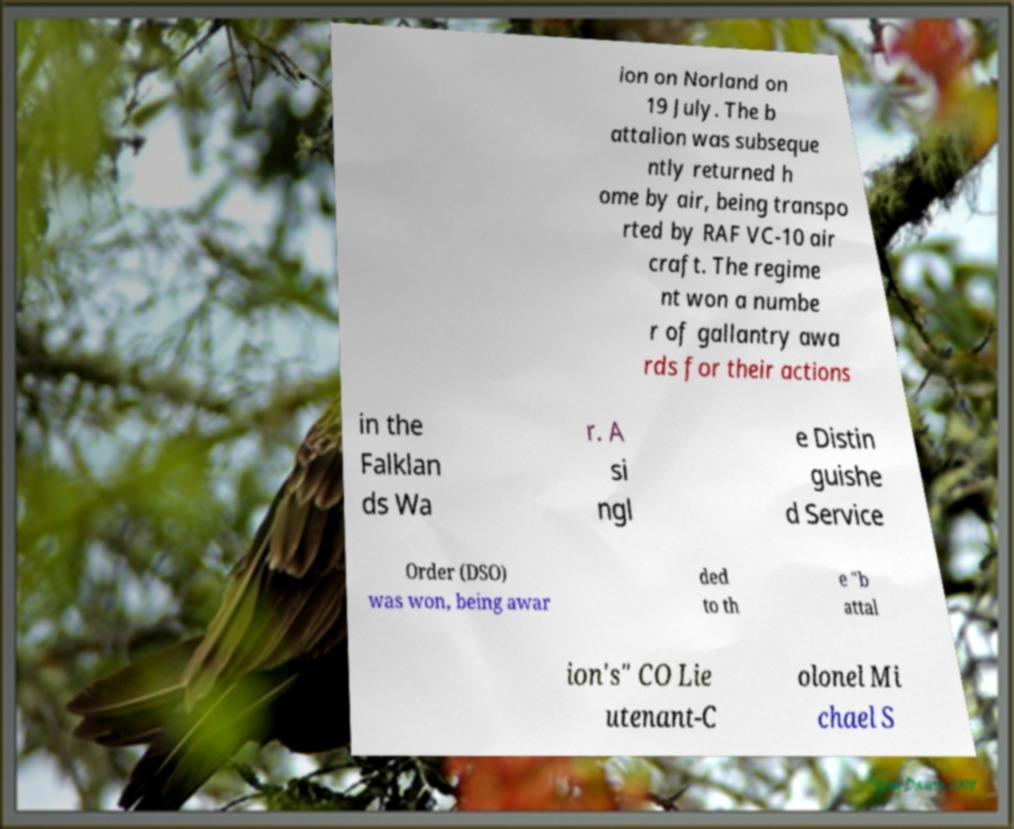Please read and relay the text visible in this image. What does it say? ion on Norland on 19 July. The b attalion was subseque ntly returned h ome by air, being transpo rted by RAF VC-10 air craft. The regime nt won a numbe r of gallantry awa rds for their actions in the Falklan ds Wa r. A si ngl e Distin guishe d Service Order (DSO) was won, being awar ded to th e "b attal ion's" CO Lie utenant-C olonel Mi chael S 